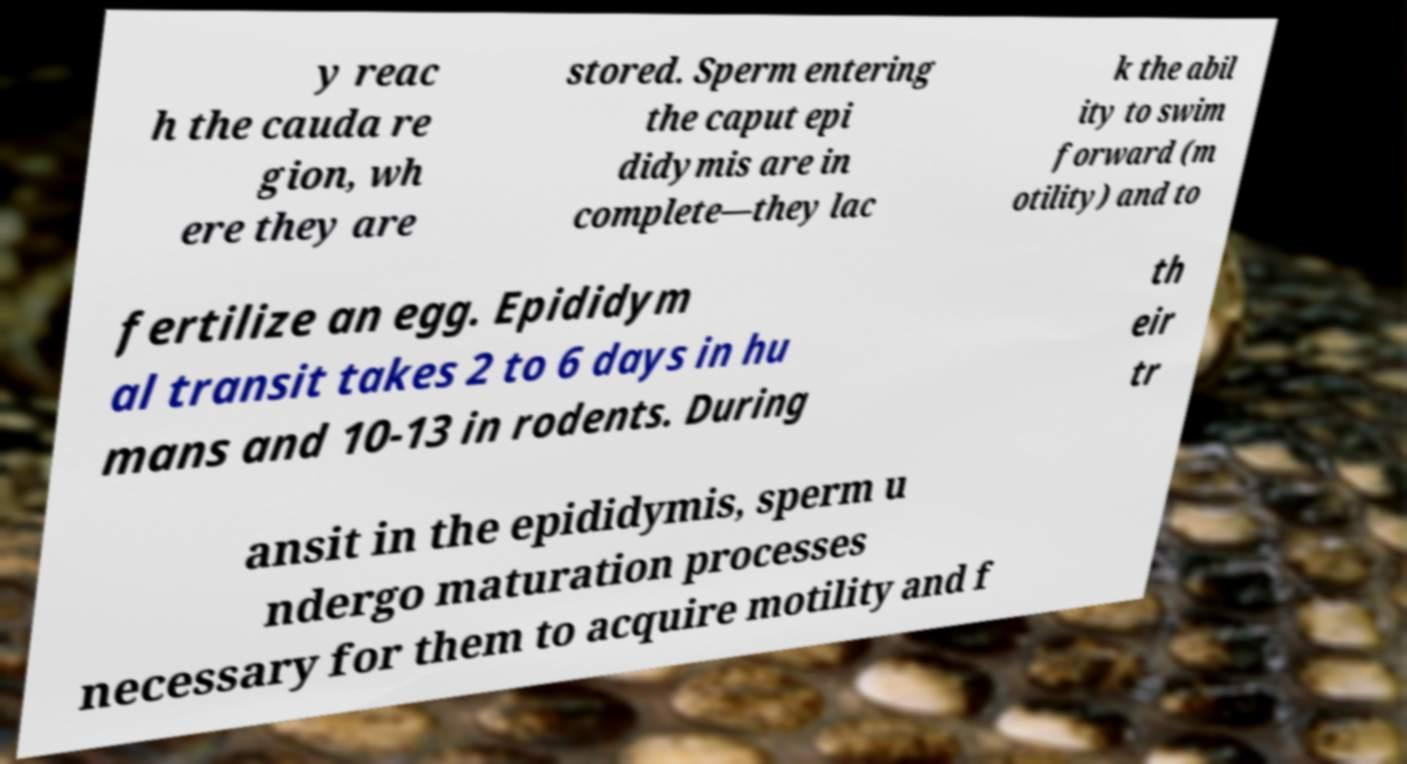Could you extract and type out the text from this image? y reac h the cauda re gion, wh ere they are stored. Sperm entering the caput epi didymis are in complete—they lac k the abil ity to swim forward (m otility) and to fertilize an egg. Epididym al transit takes 2 to 6 days in hu mans and 10-13 in rodents. During th eir tr ansit in the epididymis, sperm u ndergo maturation processes necessary for them to acquire motility and f 